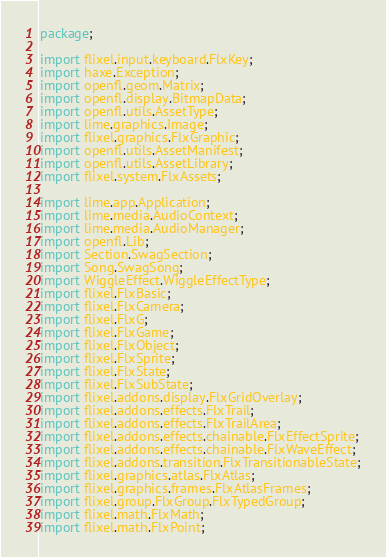<code> <loc_0><loc_0><loc_500><loc_500><_Haxe_>package;

import flixel.input.keyboard.FlxKey;
import haxe.Exception;
import openfl.geom.Matrix;
import openfl.display.BitmapData;
import openfl.utils.AssetType;
import lime.graphics.Image;
import flixel.graphics.FlxGraphic;
import openfl.utils.AssetManifest;
import openfl.utils.AssetLibrary;
import flixel.system.FlxAssets;

import lime.app.Application;
import lime.media.AudioContext;
import lime.media.AudioManager;
import openfl.Lib;
import Section.SwagSection;
import Song.SwagSong;
import WiggleEffect.WiggleEffectType;
import flixel.FlxBasic;
import flixel.FlxCamera;
import flixel.FlxG;
import flixel.FlxGame;
import flixel.FlxObject;
import flixel.FlxSprite;
import flixel.FlxState;
import flixel.FlxSubState;
import flixel.addons.display.FlxGridOverlay;
import flixel.addons.effects.FlxTrail;
import flixel.addons.effects.FlxTrailArea;
import flixel.addons.effects.chainable.FlxEffectSprite;
import flixel.addons.effects.chainable.FlxWaveEffect;
import flixel.addons.transition.FlxTransitionableState;
import flixel.graphics.atlas.FlxAtlas;
import flixel.graphics.frames.FlxAtlasFrames;
import flixel.group.FlxGroup.FlxTypedGroup;
import flixel.math.FlxMath;
import flixel.math.FlxPoint;</code> 